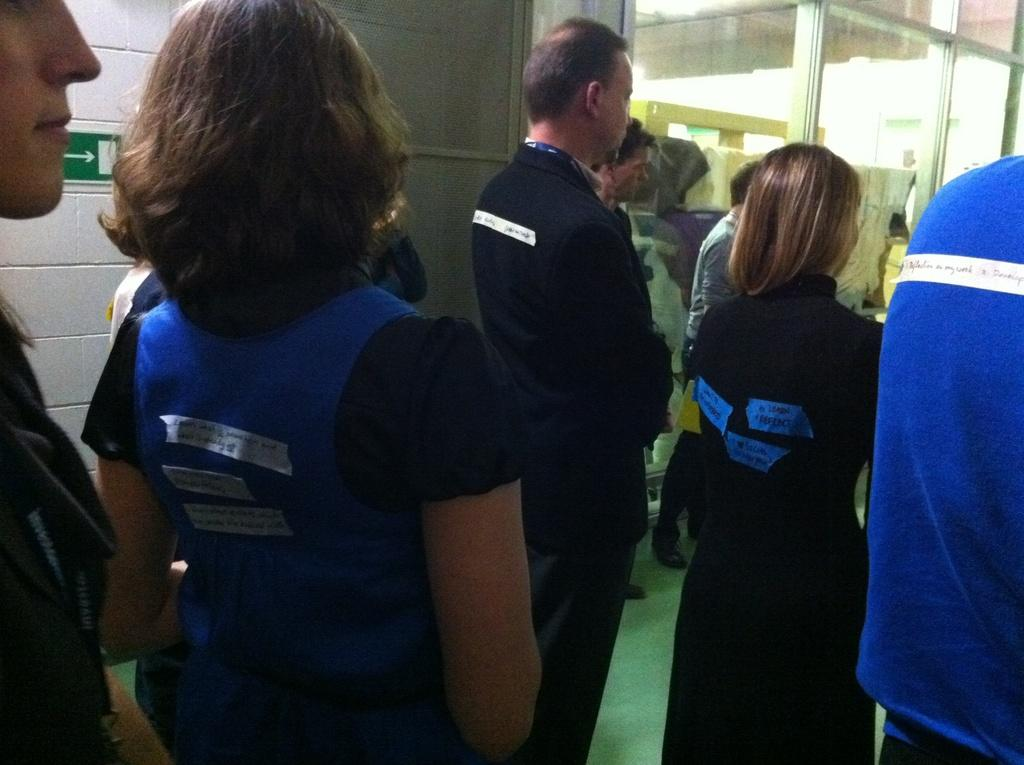What is happening in the image? There are people standing in the image. Can you describe the clothing of the people in the image? The people are wearing different color dresses. What architectural feature can be seen in the image? There is a glass door in the image. What else is present in the image? There is a wall in the image. Can you see any ladybugs on the wall in the image? There are no ladybugs visible on the wall in the image. What type of club is being used by the people in the image? There is no club present in the image; the people are simply standing. 